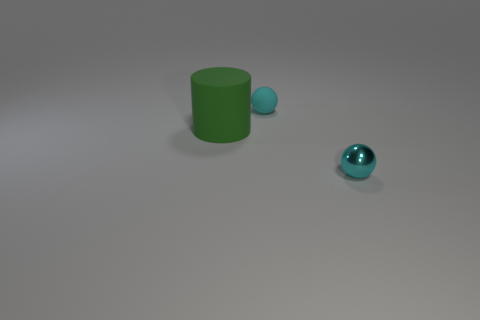Add 1 matte things. How many objects exist? 4 Subtract all spheres. How many objects are left? 1 Add 2 big green rubber objects. How many big green rubber objects exist? 3 Subtract 0 purple balls. How many objects are left? 3 Subtract all large gray rubber cylinders. Subtract all green matte objects. How many objects are left? 2 Add 3 cyan balls. How many cyan balls are left? 5 